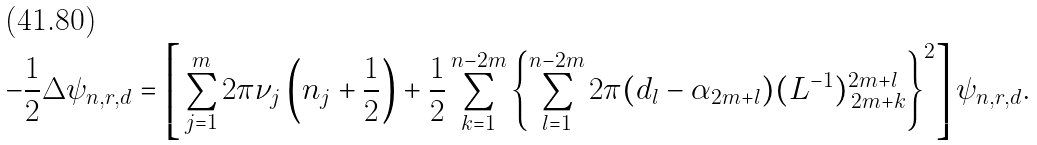Convert formula to latex. <formula><loc_0><loc_0><loc_500><loc_500>- \frac { 1 } { 2 } \Delta \psi _ { n , r , d } = \left [ \, \sum _ { j = 1 } ^ { m } 2 \pi \nu _ { j } \left ( n _ { j } + \frac { 1 } { 2 } \right ) + \frac { 1 } { 2 } \sum _ { k = 1 } ^ { n - 2 m } \left \{ \sum _ { l = 1 } ^ { n - 2 m } 2 \pi ( d _ { l } - \alpha _ { 2 m + l } ) ( L ^ { - 1 } ) ^ { 2 m + l } _ { \, 2 m + k } \right \} ^ { 2 } \right ] \psi _ { n , r , d } .</formula> 